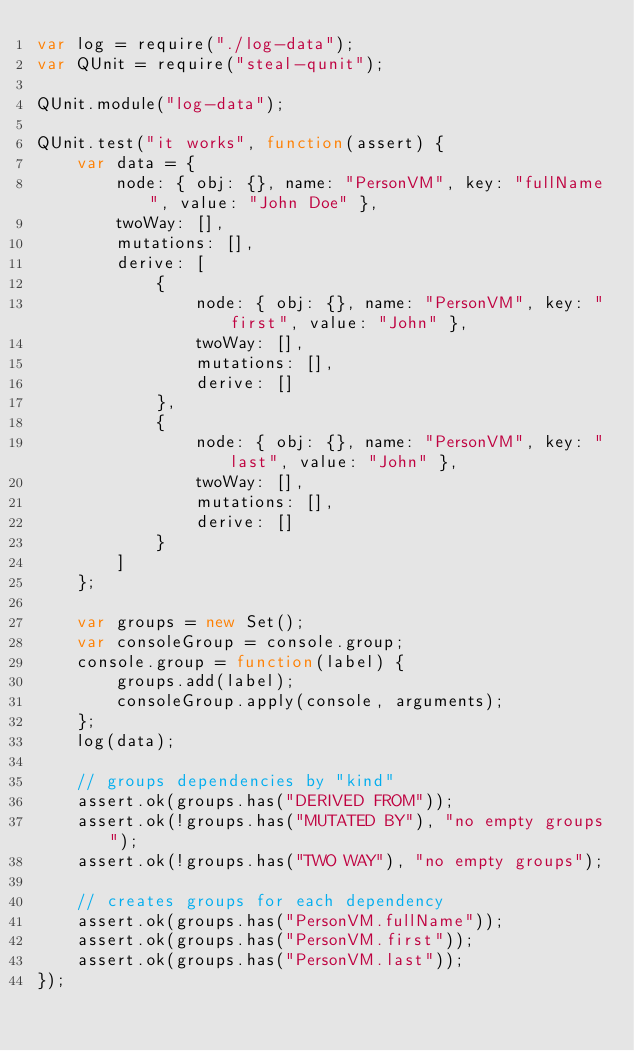Convert code to text. <code><loc_0><loc_0><loc_500><loc_500><_JavaScript_>var log = require("./log-data");
var QUnit = require("steal-qunit");

QUnit.module("log-data");

QUnit.test("it works", function(assert) {
	var data = {
		node: { obj: {}, name: "PersonVM", key: "fullName", value: "John Doe" },
		twoWay: [],
		mutations: [],
		derive: [
			{
				node: { obj: {}, name: "PersonVM", key: "first", value: "John" },
				twoWay: [],
				mutations: [],
				derive: []
			},
			{
				node: { obj: {}, name: "PersonVM", key: "last", value: "John" },
				twoWay: [],
				mutations: [],
				derive: []
			}
		]
	};

	var groups = new Set();
	var consoleGroup = console.group;
	console.group = function(label) {
		groups.add(label);
		consoleGroup.apply(console, arguments);
	};
	log(data);

	// groups dependencies by "kind"
	assert.ok(groups.has("DERIVED FROM"));
	assert.ok(!groups.has("MUTATED BY"), "no empty groups");
	assert.ok(!groups.has("TWO WAY"), "no empty groups");

	// creates groups for each dependency
	assert.ok(groups.has("PersonVM.fullName"));
	assert.ok(groups.has("PersonVM.first"));
	assert.ok(groups.has("PersonVM.last"));
});
</code> 